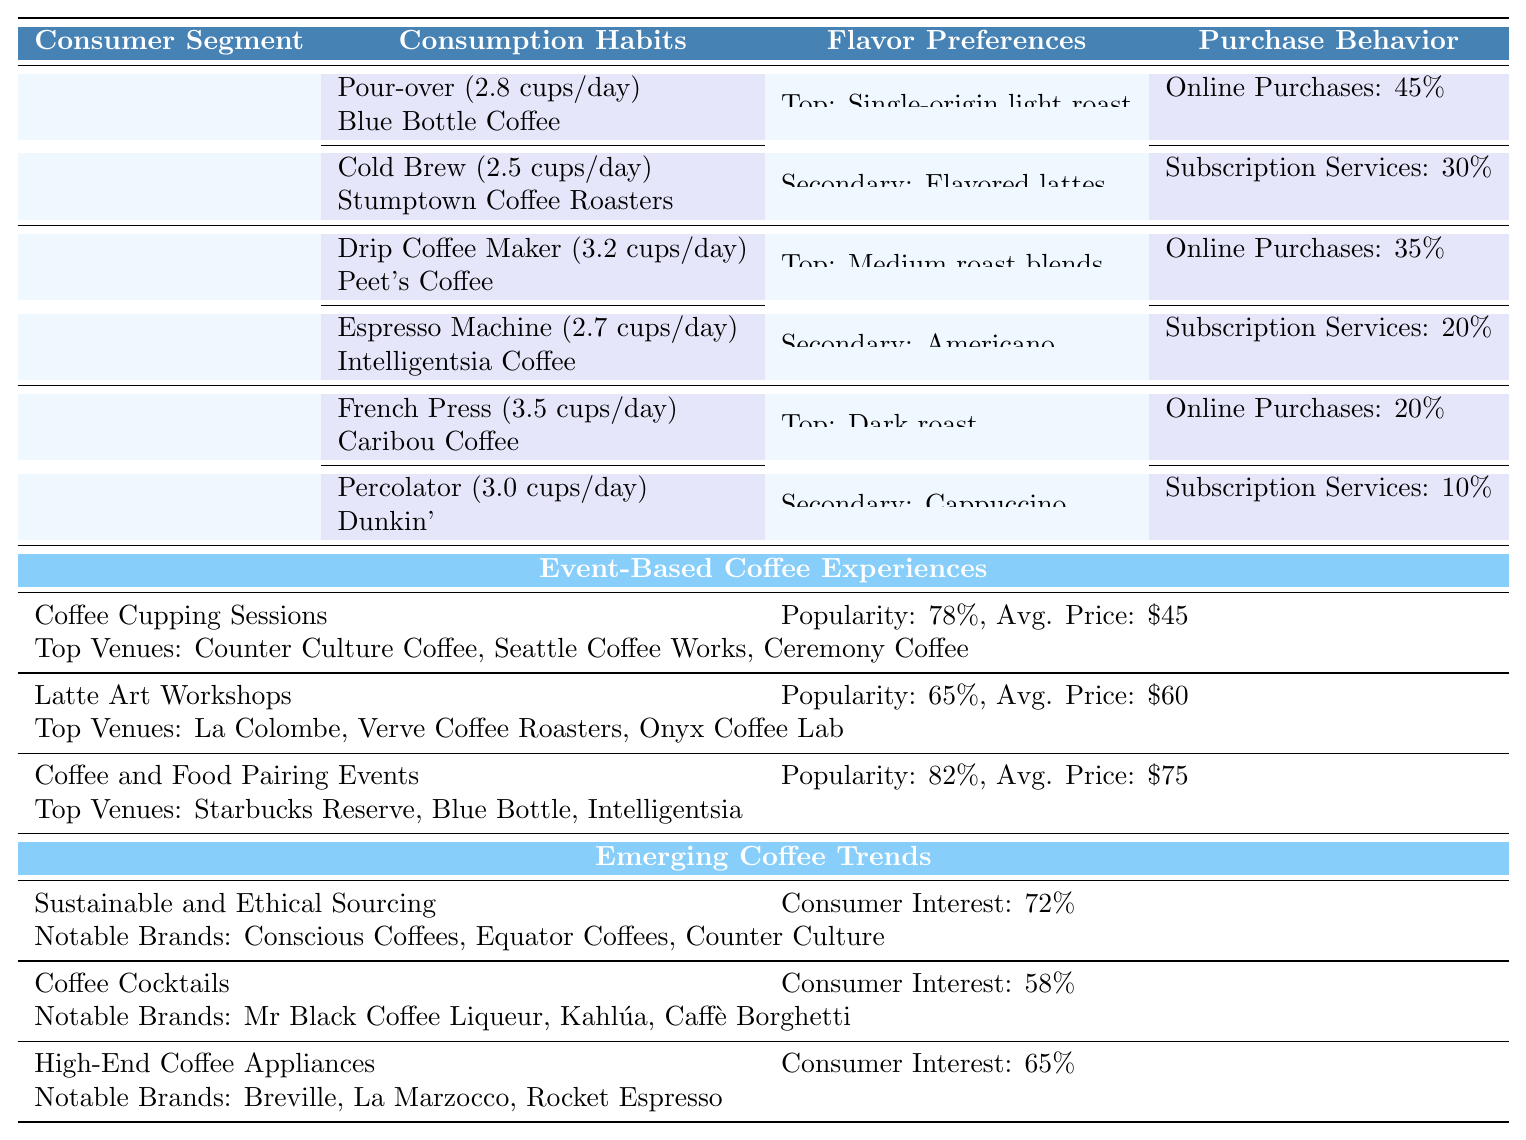What is the preferred brewing method for Millennials? The table indicates that the preferred brewing methods for Millennials include Pour-over and Cold Brew.
Answer: Pour-over Which consumer segment has the highest daily coffee consumption? The table shows Baby Boomers with a daily consumption of 3.5 cups, the highest among the segments listed.
Answer: Baby Boomers What percentage of Baby Boomers use online purchases for coffee? The table states that Baby Boomers have an online purchase percentage of 20%.
Answer: 20% Which event type has the highest popularity? From the table, Coffee and Food Pairing Events show a popularity of 82%, which is the highest of the events listed.
Answer: 82% What is the average daily consumption of coffee for Gen X? The table lists Gen X with daily consumptions of 3.2 cups (Drip Coffee Maker) and 2.7 cups (Espresso Machine). We calculate the average as (3.2 + 2.7) / 2 = 2.95 cups.
Answer: 2.95 cups Which coffee brand is associated with the trend of Sustainable and Ethical Sourcing? The table mentions Notable Brands, including Conscious Coffees, Equator Coffees, and Counter Culture for this trend.
Answer: Conscious Coffees, Equator Coffees, Counter Culture Is the average ticket price for Latte Art Workshops higher than that for Coffee Cupping Sessions? The average ticket price for Latte Art Workshops is $60 and $45 for Coffee Cupping Sessions. Since 60 > 45, the statement is true.
Answer: Yes What is the sum of the percentage of online purchases for all consumer segments? The online purchase percentages are 45% for Millennials, 35% for Gen X, and 20% for Baby Boomers. The sum is 45 + 35 + 20 = 100%.
Answer: 100% Which consumer segment has the lowest secondary flavor preference? The table indicates that for secondary preferences, Millennials have flavored lattes, Gen X has Americano, and Baby Boomers have cappuccino. There is no numerical ranking, but based on broad preference, flavored lattes may be seen as less traditional. This requires subjective reasoning; however, objectively we see no direct indication of “lowest.”
Answer: Not determinable from table data What are the notable brands associated with the trend of Coffee Cocktails? The table lists Mr Black Coffee Liqueur, Kahlúa, and Caffè Borghetti under this trend.
Answer: Mr Black Coffee Liqueur, Kahlúa, Caffè Borghetti 